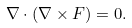<formula> <loc_0><loc_0><loc_500><loc_500>\nabla \cdot ( \nabla \times F ) = 0 .</formula> 